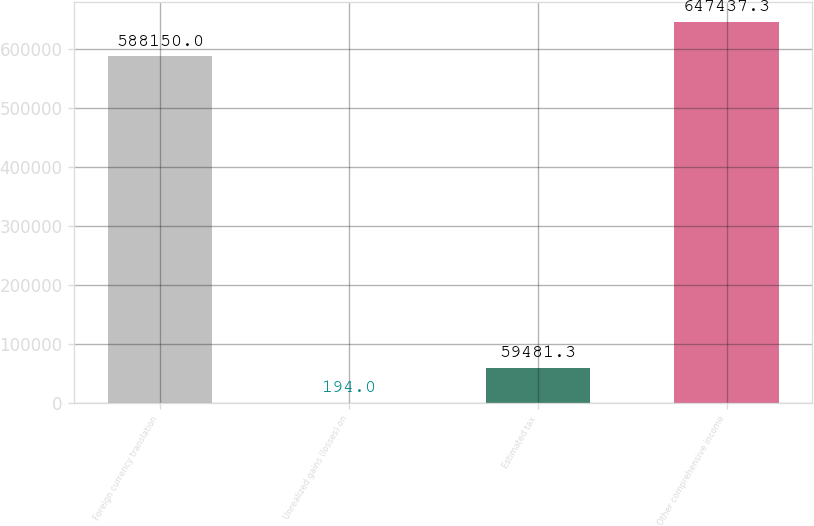<chart> <loc_0><loc_0><loc_500><loc_500><bar_chart><fcel>Foreign currency translation<fcel>Unrealized gains (losses) on<fcel>Estimated tax<fcel>Other comprehensive income<nl><fcel>588150<fcel>194<fcel>59481.3<fcel>647437<nl></chart> 